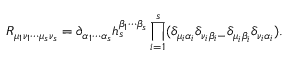<formula> <loc_0><loc_0><loc_500><loc_500>R _ { \mu _ { 1 } \nu _ { 1 } \cdots \mu _ { s } \nu _ { s } } = \partial _ { \alpha _ { 1 } \cdots \alpha _ { s } } h _ { s } ^ { \beta _ { 1 } \cdots \beta _ { s } } \prod _ { i = 1 } ^ { s } ( \delta _ { \mu _ { i } \alpha _ { i } } \delta _ { \nu _ { i } \beta _ { i } - } \delta _ { \mu _ { i } \beta _ { i } } \delta _ { \nu _ { i } \alpha _ { i } } ) .</formula> 